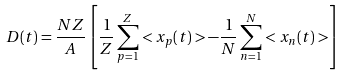Convert formula to latex. <formula><loc_0><loc_0><loc_500><loc_500>D ( t ) = \frac { N Z } { A } \left [ \frac { 1 } { Z } \sum _ { p = 1 } ^ { Z } < x _ { p } ( t ) > - \frac { 1 } { N } \sum _ { n = 1 } ^ { N } < x _ { n } ( t ) > \right ]</formula> 